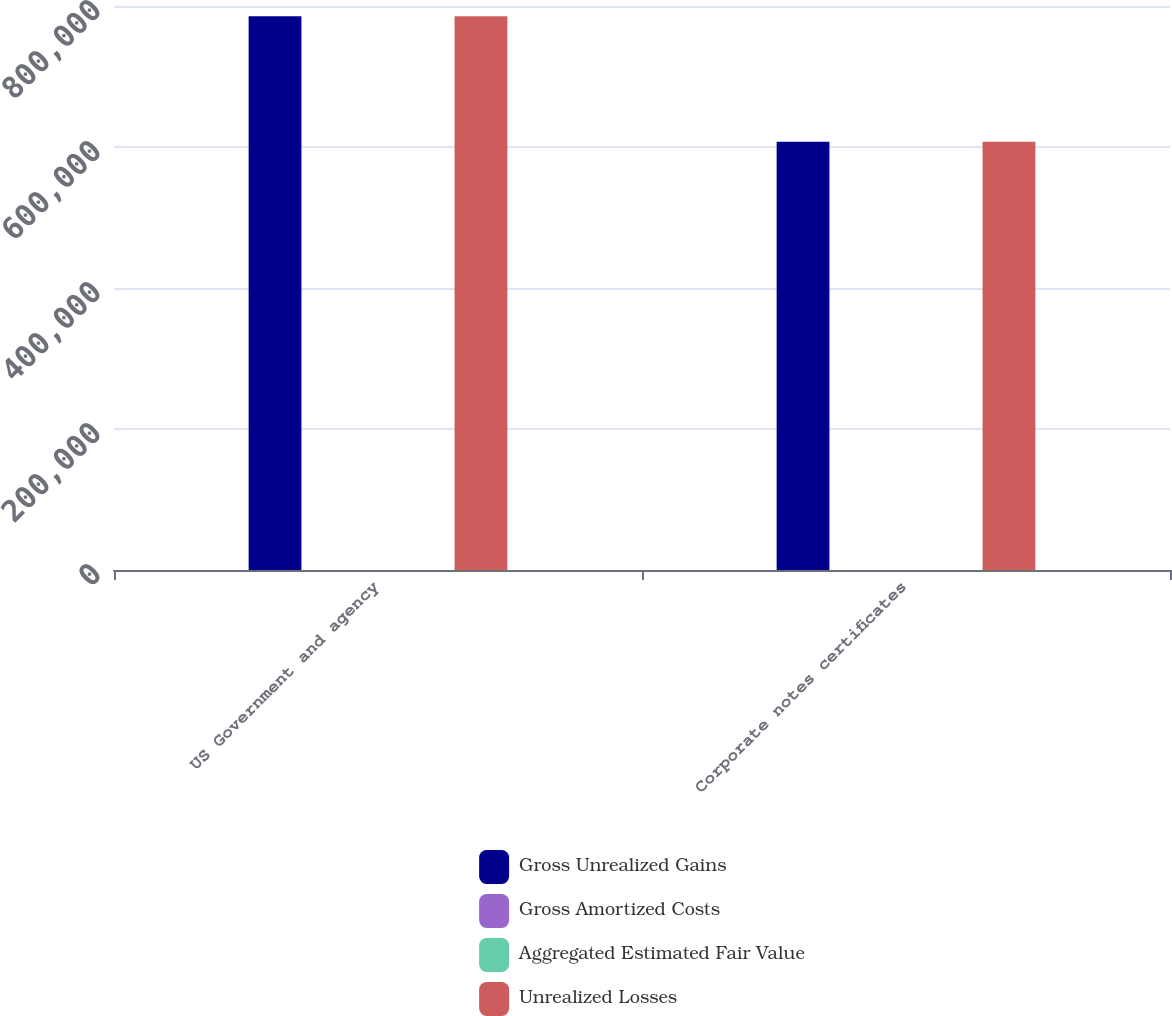Convert chart. <chart><loc_0><loc_0><loc_500><loc_500><stacked_bar_chart><ecel><fcel>US Government and agency<fcel>Corporate notes certificates<nl><fcel>Gross Unrealized Gains<fcel>785535<fcel>607590<nl><fcel>Gross Amortized Costs<fcel>22<fcel>11<nl><fcel>Aggregated Estimated Fair Value<fcel>21<fcel>93<nl><fcel>Unrealized Losses<fcel>785536<fcel>607508<nl></chart> 